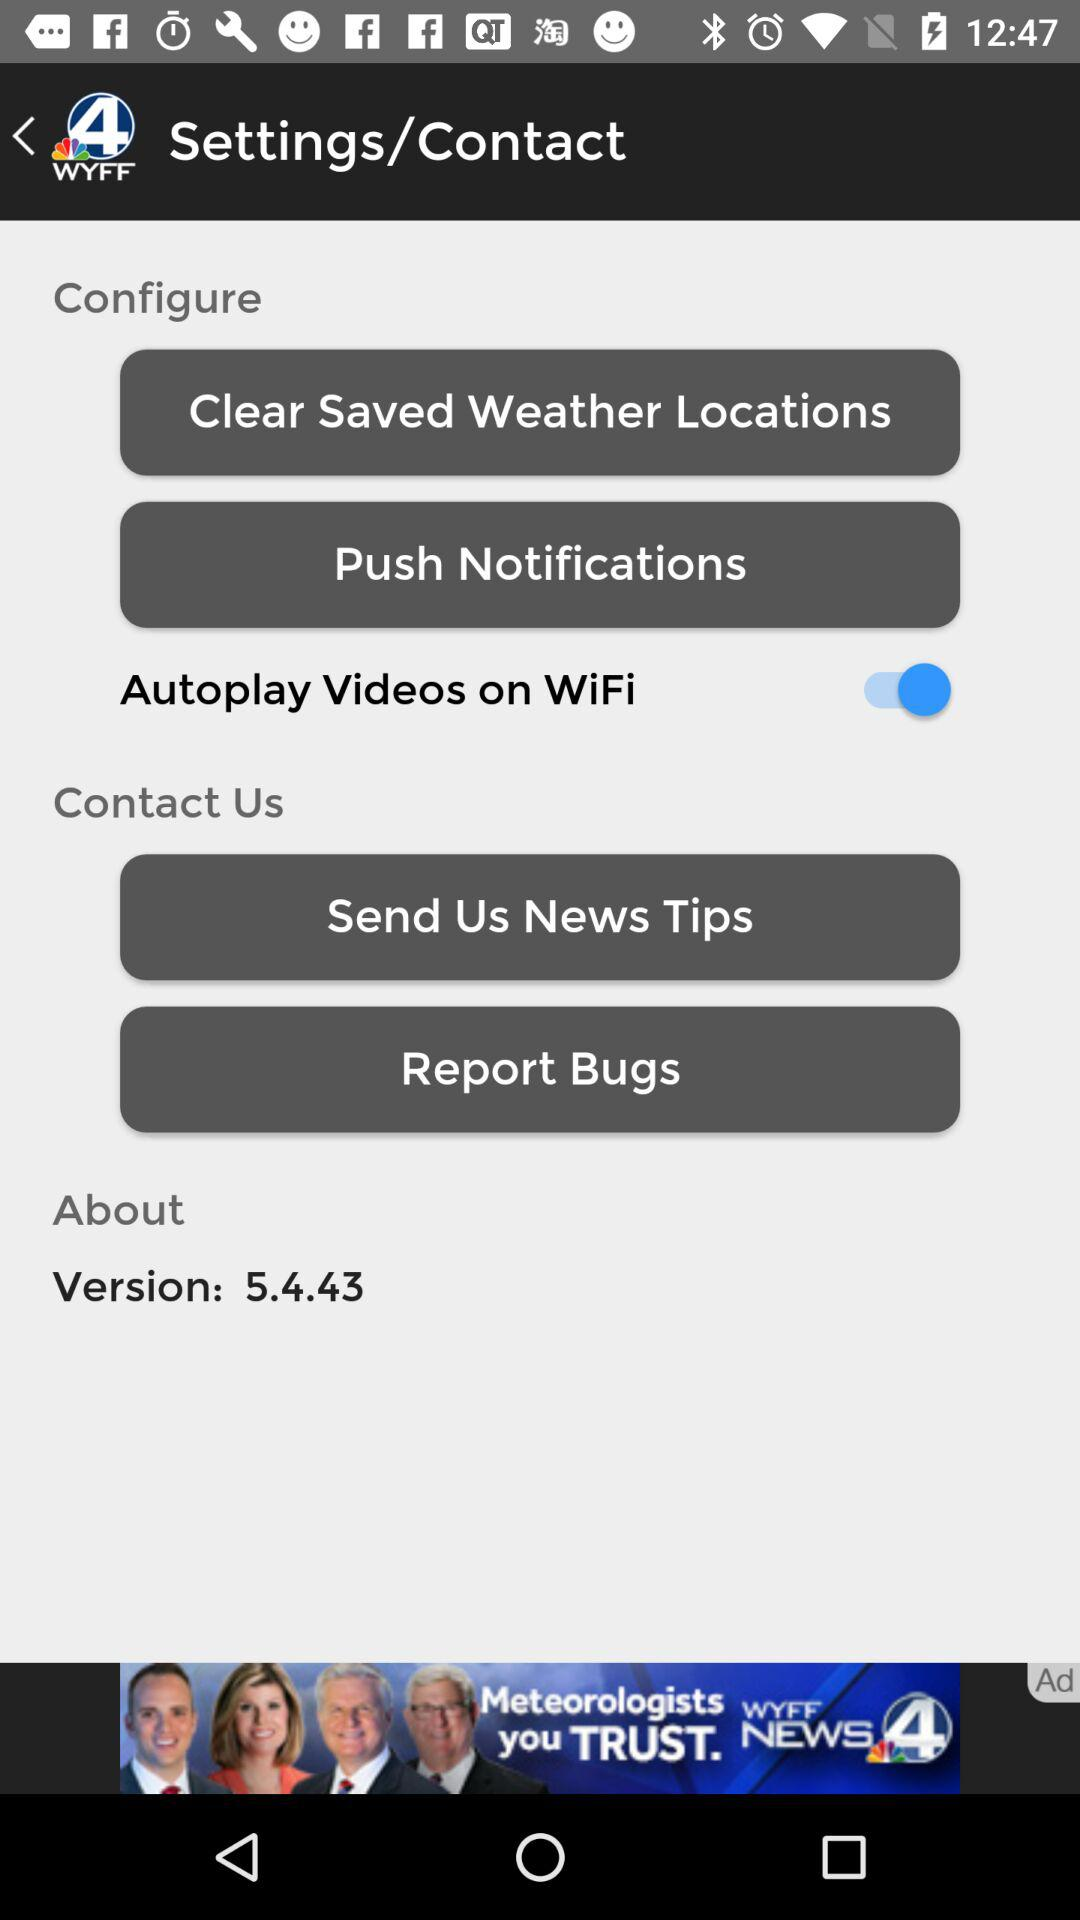What version is available? The available version is 5.4.43. 